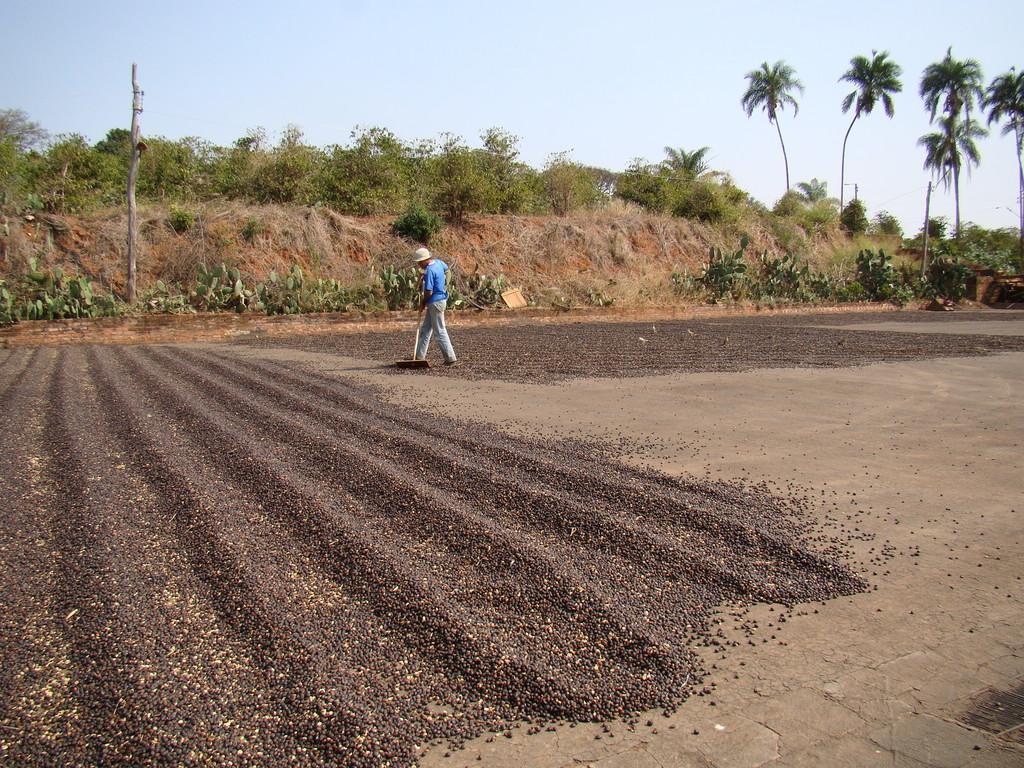Please provide a concise description of this image. In this image I can see the ground and few black and cream colored objects on the ground. I can see a person standing and holding an object in his hand. In the background I can see few trees, few poles and the sky. 